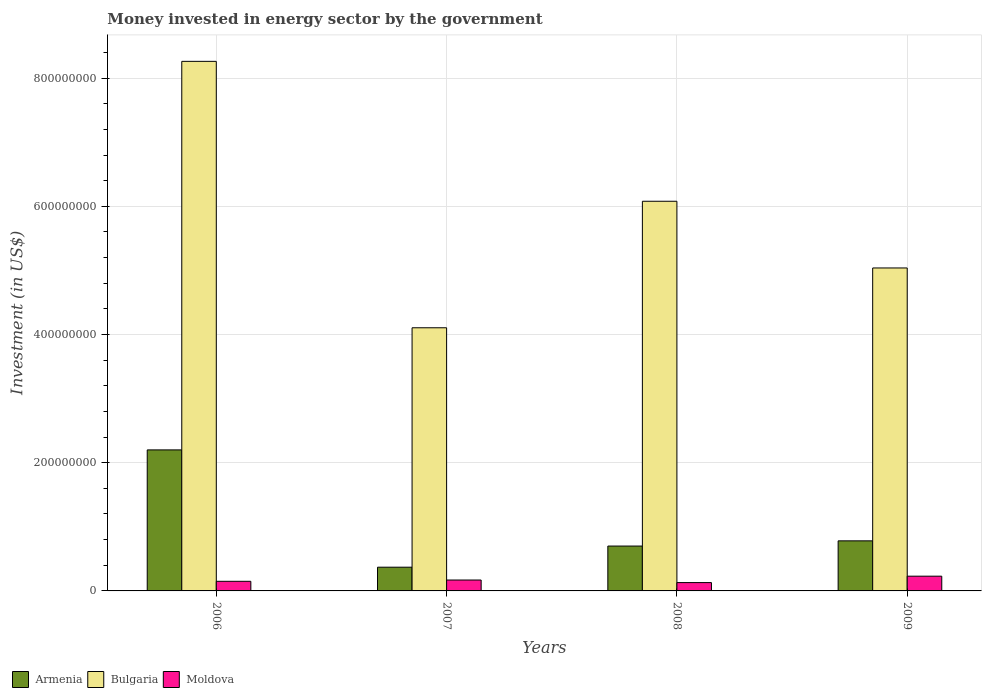How many different coloured bars are there?
Keep it short and to the point. 3. Are the number of bars per tick equal to the number of legend labels?
Ensure brevity in your answer.  Yes. Are the number of bars on each tick of the X-axis equal?
Your answer should be compact. Yes. How many bars are there on the 2nd tick from the left?
Offer a terse response. 3. How many bars are there on the 3rd tick from the right?
Ensure brevity in your answer.  3. What is the label of the 2nd group of bars from the left?
Make the answer very short. 2007. In how many cases, is the number of bars for a given year not equal to the number of legend labels?
Give a very brief answer. 0. What is the money spent in energy sector in Armenia in 2007?
Keep it short and to the point. 3.70e+07. Across all years, what is the maximum money spent in energy sector in Armenia?
Provide a short and direct response. 2.20e+08. Across all years, what is the minimum money spent in energy sector in Bulgaria?
Ensure brevity in your answer.  4.10e+08. In which year was the money spent in energy sector in Moldova minimum?
Give a very brief answer. 2008. What is the total money spent in energy sector in Bulgaria in the graph?
Make the answer very short. 2.35e+09. What is the difference between the money spent in energy sector in Armenia in 2006 and that in 2007?
Offer a very short reply. 1.83e+08. What is the difference between the money spent in energy sector in Armenia in 2008 and the money spent in energy sector in Moldova in 2009?
Provide a short and direct response. 4.70e+07. What is the average money spent in energy sector in Bulgaria per year?
Make the answer very short. 5.87e+08. In the year 2006, what is the difference between the money spent in energy sector in Bulgaria and money spent in energy sector in Armenia?
Keep it short and to the point. 6.06e+08. What is the ratio of the money spent in energy sector in Moldova in 2007 to that in 2008?
Keep it short and to the point. 1.31. Is the money spent in energy sector in Armenia in 2007 less than that in 2008?
Offer a very short reply. Yes. Is the difference between the money spent in energy sector in Bulgaria in 2006 and 2007 greater than the difference between the money spent in energy sector in Armenia in 2006 and 2007?
Your response must be concise. Yes. What is the difference between the highest and the second highest money spent in energy sector in Moldova?
Keep it short and to the point. 6.00e+06. What is the difference between the highest and the lowest money spent in energy sector in Armenia?
Provide a succinct answer. 1.83e+08. In how many years, is the money spent in energy sector in Bulgaria greater than the average money spent in energy sector in Bulgaria taken over all years?
Your response must be concise. 2. What does the 3rd bar from the left in 2009 represents?
Your answer should be compact. Moldova. What does the 3rd bar from the right in 2008 represents?
Keep it short and to the point. Armenia. Is it the case that in every year, the sum of the money spent in energy sector in Moldova and money spent in energy sector in Bulgaria is greater than the money spent in energy sector in Armenia?
Offer a terse response. Yes. How many bars are there?
Offer a very short reply. 12. Are all the bars in the graph horizontal?
Provide a short and direct response. No. How many years are there in the graph?
Give a very brief answer. 4. Does the graph contain any zero values?
Give a very brief answer. No. Where does the legend appear in the graph?
Provide a succinct answer. Bottom left. How many legend labels are there?
Give a very brief answer. 3. What is the title of the graph?
Your answer should be compact. Money invested in energy sector by the government. Does "United Arab Emirates" appear as one of the legend labels in the graph?
Keep it short and to the point. No. What is the label or title of the Y-axis?
Offer a very short reply. Investment (in US$). What is the Investment (in US$) in Armenia in 2006?
Provide a short and direct response. 2.20e+08. What is the Investment (in US$) of Bulgaria in 2006?
Ensure brevity in your answer.  8.26e+08. What is the Investment (in US$) in Moldova in 2006?
Offer a very short reply. 1.50e+07. What is the Investment (in US$) of Armenia in 2007?
Your answer should be compact. 3.70e+07. What is the Investment (in US$) in Bulgaria in 2007?
Offer a very short reply. 4.10e+08. What is the Investment (in US$) of Moldova in 2007?
Offer a very short reply. 1.70e+07. What is the Investment (in US$) of Armenia in 2008?
Give a very brief answer. 7.00e+07. What is the Investment (in US$) of Bulgaria in 2008?
Your answer should be very brief. 6.08e+08. What is the Investment (in US$) of Moldova in 2008?
Ensure brevity in your answer.  1.30e+07. What is the Investment (in US$) in Armenia in 2009?
Give a very brief answer. 7.81e+07. What is the Investment (in US$) of Bulgaria in 2009?
Provide a succinct answer. 5.04e+08. What is the Investment (in US$) in Moldova in 2009?
Your answer should be compact. 2.30e+07. Across all years, what is the maximum Investment (in US$) in Armenia?
Ensure brevity in your answer.  2.20e+08. Across all years, what is the maximum Investment (in US$) of Bulgaria?
Offer a very short reply. 8.26e+08. Across all years, what is the maximum Investment (in US$) of Moldova?
Provide a succinct answer. 2.30e+07. Across all years, what is the minimum Investment (in US$) of Armenia?
Keep it short and to the point. 3.70e+07. Across all years, what is the minimum Investment (in US$) in Bulgaria?
Offer a terse response. 4.10e+08. Across all years, what is the minimum Investment (in US$) in Moldova?
Give a very brief answer. 1.30e+07. What is the total Investment (in US$) in Armenia in the graph?
Offer a very short reply. 4.05e+08. What is the total Investment (in US$) of Bulgaria in the graph?
Your answer should be compact. 2.35e+09. What is the total Investment (in US$) of Moldova in the graph?
Give a very brief answer. 6.80e+07. What is the difference between the Investment (in US$) of Armenia in 2006 and that in 2007?
Give a very brief answer. 1.83e+08. What is the difference between the Investment (in US$) in Bulgaria in 2006 and that in 2007?
Offer a terse response. 4.16e+08. What is the difference between the Investment (in US$) of Moldova in 2006 and that in 2007?
Your answer should be compact. -2.00e+06. What is the difference between the Investment (in US$) of Armenia in 2006 and that in 2008?
Make the answer very short. 1.50e+08. What is the difference between the Investment (in US$) of Bulgaria in 2006 and that in 2008?
Ensure brevity in your answer.  2.18e+08. What is the difference between the Investment (in US$) in Moldova in 2006 and that in 2008?
Provide a succinct answer. 2.00e+06. What is the difference between the Investment (in US$) in Armenia in 2006 and that in 2009?
Make the answer very short. 1.42e+08. What is the difference between the Investment (in US$) in Bulgaria in 2006 and that in 2009?
Provide a succinct answer. 3.22e+08. What is the difference between the Investment (in US$) in Moldova in 2006 and that in 2009?
Your answer should be compact. -8.00e+06. What is the difference between the Investment (in US$) in Armenia in 2007 and that in 2008?
Ensure brevity in your answer.  -3.30e+07. What is the difference between the Investment (in US$) in Bulgaria in 2007 and that in 2008?
Keep it short and to the point. -1.97e+08. What is the difference between the Investment (in US$) in Armenia in 2007 and that in 2009?
Your answer should be very brief. -4.11e+07. What is the difference between the Investment (in US$) of Bulgaria in 2007 and that in 2009?
Provide a succinct answer. -9.33e+07. What is the difference between the Investment (in US$) of Moldova in 2007 and that in 2009?
Your answer should be compact. -6.00e+06. What is the difference between the Investment (in US$) of Armenia in 2008 and that in 2009?
Provide a succinct answer. -8.10e+06. What is the difference between the Investment (in US$) in Bulgaria in 2008 and that in 2009?
Provide a short and direct response. 1.04e+08. What is the difference between the Investment (in US$) of Moldova in 2008 and that in 2009?
Your answer should be compact. -1.00e+07. What is the difference between the Investment (in US$) in Armenia in 2006 and the Investment (in US$) in Bulgaria in 2007?
Provide a short and direct response. -1.90e+08. What is the difference between the Investment (in US$) of Armenia in 2006 and the Investment (in US$) of Moldova in 2007?
Offer a terse response. 2.03e+08. What is the difference between the Investment (in US$) in Bulgaria in 2006 and the Investment (in US$) in Moldova in 2007?
Ensure brevity in your answer.  8.09e+08. What is the difference between the Investment (in US$) of Armenia in 2006 and the Investment (in US$) of Bulgaria in 2008?
Make the answer very short. -3.88e+08. What is the difference between the Investment (in US$) of Armenia in 2006 and the Investment (in US$) of Moldova in 2008?
Make the answer very short. 2.07e+08. What is the difference between the Investment (in US$) in Bulgaria in 2006 and the Investment (in US$) in Moldova in 2008?
Your answer should be compact. 8.13e+08. What is the difference between the Investment (in US$) of Armenia in 2006 and the Investment (in US$) of Bulgaria in 2009?
Offer a very short reply. -2.84e+08. What is the difference between the Investment (in US$) in Armenia in 2006 and the Investment (in US$) in Moldova in 2009?
Give a very brief answer. 1.97e+08. What is the difference between the Investment (in US$) of Bulgaria in 2006 and the Investment (in US$) of Moldova in 2009?
Keep it short and to the point. 8.03e+08. What is the difference between the Investment (in US$) of Armenia in 2007 and the Investment (in US$) of Bulgaria in 2008?
Keep it short and to the point. -5.71e+08. What is the difference between the Investment (in US$) in Armenia in 2007 and the Investment (in US$) in Moldova in 2008?
Your answer should be very brief. 2.40e+07. What is the difference between the Investment (in US$) in Bulgaria in 2007 and the Investment (in US$) in Moldova in 2008?
Your answer should be compact. 3.98e+08. What is the difference between the Investment (in US$) of Armenia in 2007 and the Investment (in US$) of Bulgaria in 2009?
Keep it short and to the point. -4.67e+08. What is the difference between the Investment (in US$) in Armenia in 2007 and the Investment (in US$) in Moldova in 2009?
Make the answer very short. 1.40e+07. What is the difference between the Investment (in US$) of Bulgaria in 2007 and the Investment (in US$) of Moldova in 2009?
Your answer should be very brief. 3.88e+08. What is the difference between the Investment (in US$) of Armenia in 2008 and the Investment (in US$) of Bulgaria in 2009?
Your answer should be compact. -4.34e+08. What is the difference between the Investment (in US$) of Armenia in 2008 and the Investment (in US$) of Moldova in 2009?
Your answer should be very brief. 4.70e+07. What is the difference between the Investment (in US$) of Bulgaria in 2008 and the Investment (in US$) of Moldova in 2009?
Provide a short and direct response. 5.85e+08. What is the average Investment (in US$) in Armenia per year?
Give a very brief answer. 1.01e+08. What is the average Investment (in US$) in Bulgaria per year?
Give a very brief answer. 5.87e+08. What is the average Investment (in US$) in Moldova per year?
Your answer should be compact. 1.70e+07. In the year 2006, what is the difference between the Investment (in US$) in Armenia and Investment (in US$) in Bulgaria?
Ensure brevity in your answer.  -6.06e+08. In the year 2006, what is the difference between the Investment (in US$) in Armenia and Investment (in US$) in Moldova?
Ensure brevity in your answer.  2.05e+08. In the year 2006, what is the difference between the Investment (in US$) of Bulgaria and Investment (in US$) of Moldova?
Make the answer very short. 8.11e+08. In the year 2007, what is the difference between the Investment (in US$) of Armenia and Investment (in US$) of Bulgaria?
Provide a succinct answer. -3.74e+08. In the year 2007, what is the difference between the Investment (in US$) in Bulgaria and Investment (in US$) in Moldova?
Provide a succinct answer. 3.94e+08. In the year 2008, what is the difference between the Investment (in US$) of Armenia and Investment (in US$) of Bulgaria?
Give a very brief answer. -5.38e+08. In the year 2008, what is the difference between the Investment (in US$) in Armenia and Investment (in US$) in Moldova?
Make the answer very short. 5.70e+07. In the year 2008, what is the difference between the Investment (in US$) in Bulgaria and Investment (in US$) in Moldova?
Your response must be concise. 5.95e+08. In the year 2009, what is the difference between the Investment (in US$) in Armenia and Investment (in US$) in Bulgaria?
Give a very brief answer. -4.26e+08. In the year 2009, what is the difference between the Investment (in US$) in Armenia and Investment (in US$) in Moldova?
Give a very brief answer. 5.51e+07. In the year 2009, what is the difference between the Investment (in US$) of Bulgaria and Investment (in US$) of Moldova?
Your response must be concise. 4.81e+08. What is the ratio of the Investment (in US$) of Armenia in 2006 to that in 2007?
Your response must be concise. 5.95. What is the ratio of the Investment (in US$) of Bulgaria in 2006 to that in 2007?
Your answer should be very brief. 2.01. What is the ratio of the Investment (in US$) of Moldova in 2006 to that in 2007?
Give a very brief answer. 0.88. What is the ratio of the Investment (in US$) of Armenia in 2006 to that in 2008?
Offer a very short reply. 3.14. What is the ratio of the Investment (in US$) of Bulgaria in 2006 to that in 2008?
Offer a terse response. 1.36. What is the ratio of the Investment (in US$) in Moldova in 2006 to that in 2008?
Make the answer very short. 1.15. What is the ratio of the Investment (in US$) in Armenia in 2006 to that in 2009?
Give a very brief answer. 2.82. What is the ratio of the Investment (in US$) in Bulgaria in 2006 to that in 2009?
Your answer should be compact. 1.64. What is the ratio of the Investment (in US$) of Moldova in 2006 to that in 2009?
Ensure brevity in your answer.  0.65. What is the ratio of the Investment (in US$) of Armenia in 2007 to that in 2008?
Provide a succinct answer. 0.53. What is the ratio of the Investment (in US$) of Bulgaria in 2007 to that in 2008?
Your answer should be very brief. 0.68. What is the ratio of the Investment (in US$) of Moldova in 2007 to that in 2008?
Give a very brief answer. 1.31. What is the ratio of the Investment (in US$) in Armenia in 2007 to that in 2009?
Offer a terse response. 0.47. What is the ratio of the Investment (in US$) of Bulgaria in 2007 to that in 2009?
Give a very brief answer. 0.81. What is the ratio of the Investment (in US$) in Moldova in 2007 to that in 2009?
Give a very brief answer. 0.74. What is the ratio of the Investment (in US$) of Armenia in 2008 to that in 2009?
Your response must be concise. 0.9. What is the ratio of the Investment (in US$) of Bulgaria in 2008 to that in 2009?
Your response must be concise. 1.21. What is the ratio of the Investment (in US$) of Moldova in 2008 to that in 2009?
Offer a very short reply. 0.57. What is the difference between the highest and the second highest Investment (in US$) of Armenia?
Your answer should be very brief. 1.42e+08. What is the difference between the highest and the second highest Investment (in US$) in Bulgaria?
Keep it short and to the point. 2.18e+08. What is the difference between the highest and the second highest Investment (in US$) of Moldova?
Provide a succinct answer. 6.00e+06. What is the difference between the highest and the lowest Investment (in US$) in Armenia?
Your answer should be very brief. 1.83e+08. What is the difference between the highest and the lowest Investment (in US$) of Bulgaria?
Your answer should be very brief. 4.16e+08. 